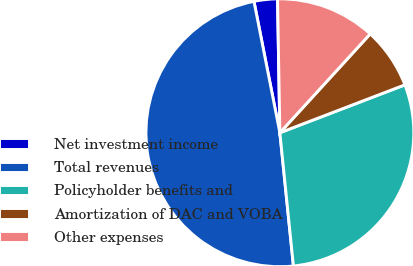Convert chart. <chart><loc_0><loc_0><loc_500><loc_500><pie_chart><fcel>Net investment income<fcel>Total revenues<fcel>Policyholder benefits and<fcel>Amortization of DAC and VOBA<fcel>Other expenses<nl><fcel>2.82%<fcel>48.51%<fcel>29.21%<fcel>7.39%<fcel>12.06%<nl></chart> 